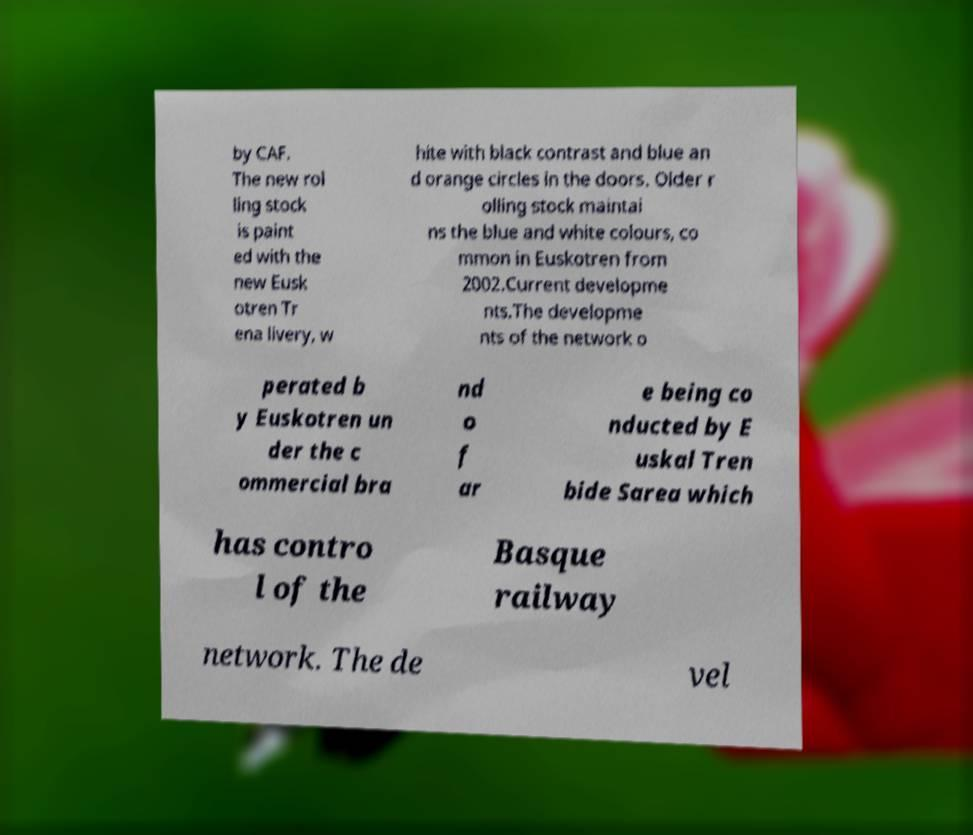What messages or text are displayed in this image? I need them in a readable, typed format. by CAF. The new rol ling stock is paint ed with the new Eusk otren Tr ena livery, w hite with black contrast and blue an d orange circles in the doors. Older r olling stock maintai ns the blue and white colours, co mmon in Euskotren from 2002.Current developme nts.The developme nts of the network o perated b y Euskotren un der the c ommercial bra nd o f ar e being co nducted by E uskal Tren bide Sarea which has contro l of the Basque railway network. The de vel 